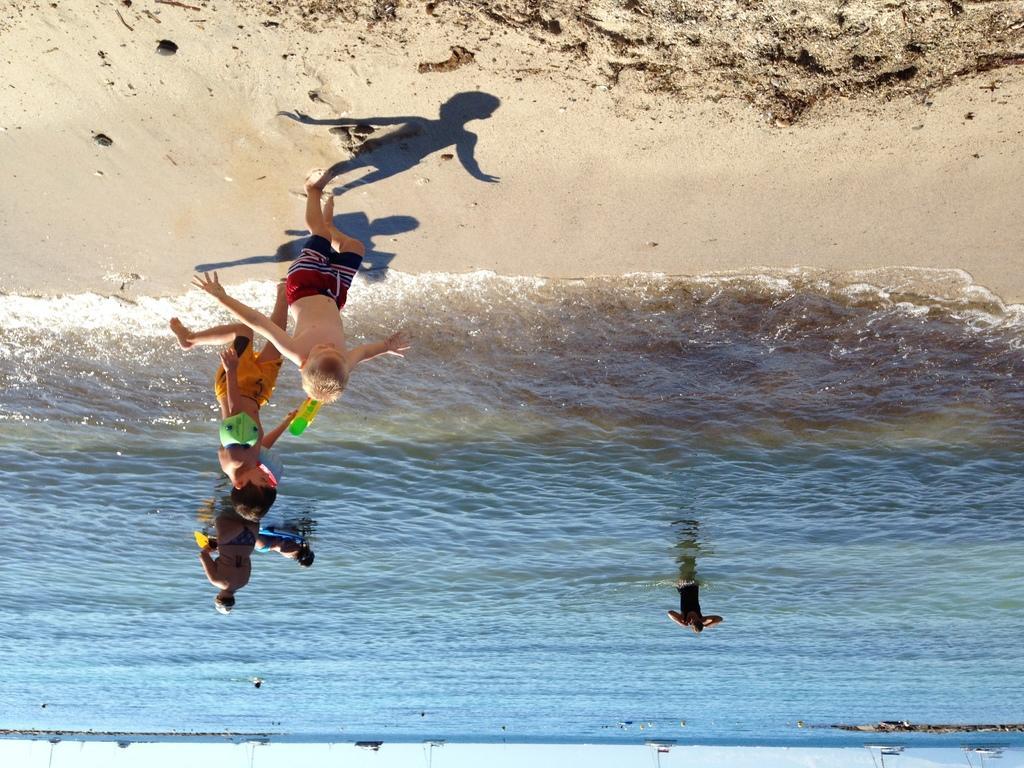Could you give a brief overview of what you see in this image? Here we can see water, sand and people. Far there are boats.  